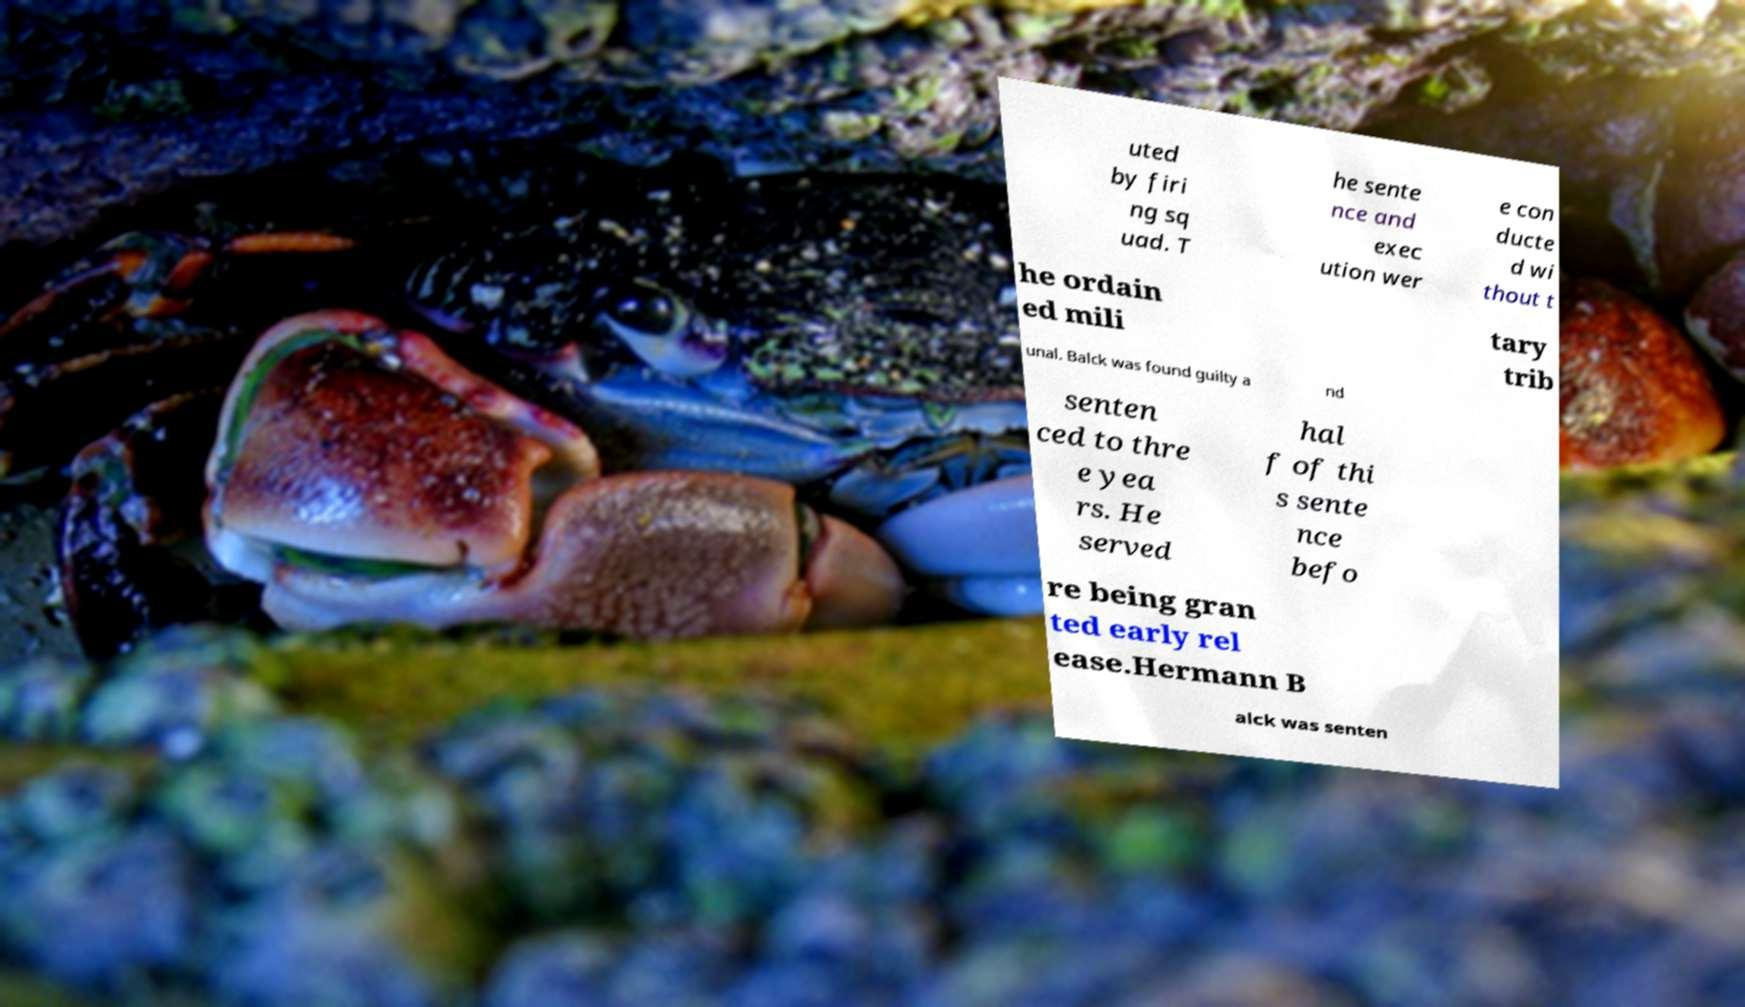There's text embedded in this image that I need extracted. Can you transcribe it verbatim? uted by firi ng sq uad. T he sente nce and exec ution wer e con ducte d wi thout t he ordain ed mili tary trib unal. Balck was found guilty a nd senten ced to thre e yea rs. He served hal f of thi s sente nce befo re being gran ted early rel ease.Hermann B alck was senten 